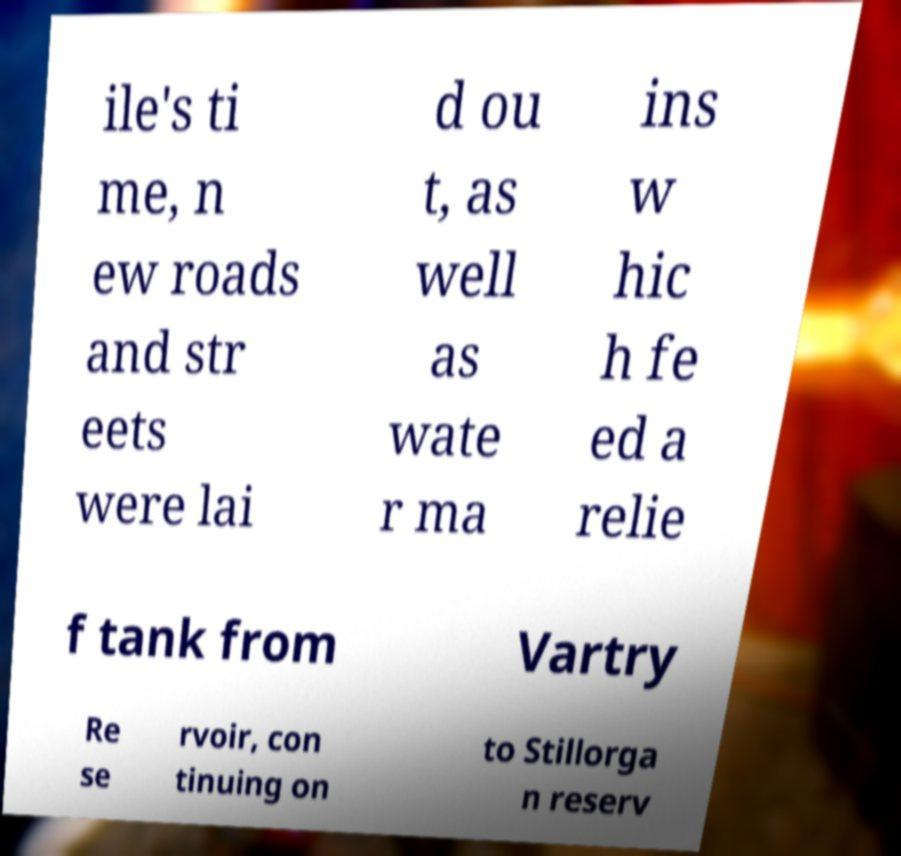Could you extract and type out the text from this image? ile's ti me, n ew roads and str eets were lai d ou t, as well as wate r ma ins w hic h fe ed a relie f tank from Vartry Re se rvoir, con tinuing on to Stillorga n reserv 